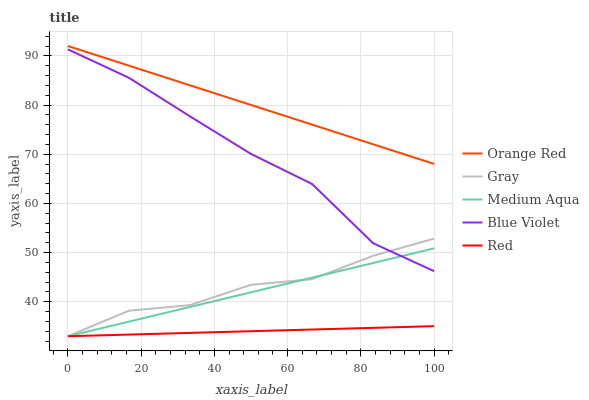Does Red have the minimum area under the curve?
Answer yes or no. Yes. Does Orange Red have the maximum area under the curve?
Answer yes or no. Yes. Does Medium Aqua have the minimum area under the curve?
Answer yes or no. No. Does Medium Aqua have the maximum area under the curve?
Answer yes or no. No. Is Medium Aqua the smoothest?
Answer yes or no. Yes. Is Blue Violet the roughest?
Answer yes or no. Yes. Is Red the smoothest?
Answer yes or no. No. Is Red the roughest?
Answer yes or no. No. Does Gray have the lowest value?
Answer yes or no. Yes. Does Orange Red have the lowest value?
Answer yes or no. No. Does Orange Red have the highest value?
Answer yes or no. Yes. Does Medium Aqua have the highest value?
Answer yes or no. No. Is Medium Aqua less than Orange Red?
Answer yes or no. Yes. Is Blue Violet greater than Red?
Answer yes or no. Yes. Does Gray intersect Blue Violet?
Answer yes or no. Yes. Is Gray less than Blue Violet?
Answer yes or no. No. Is Gray greater than Blue Violet?
Answer yes or no. No. Does Medium Aqua intersect Orange Red?
Answer yes or no. No. 